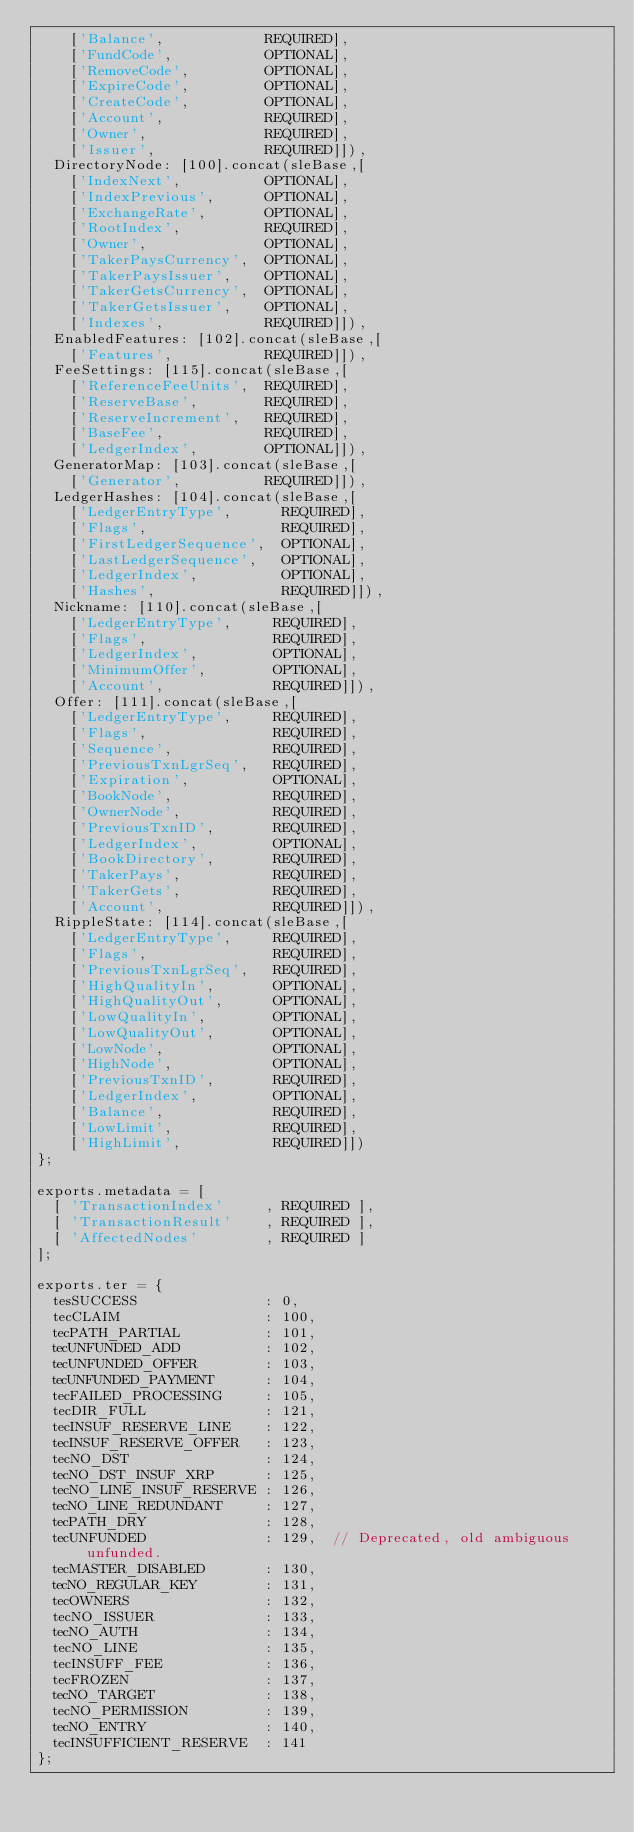<code> <loc_0><loc_0><loc_500><loc_500><_JavaScript_>    ['Balance',            REQUIRED],
    ['FundCode',           OPTIONAL],
    ['RemoveCode',         OPTIONAL],
    ['ExpireCode',         OPTIONAL],
    ['CreateCode',         OPTIONAL],
    ['Account',            REQUIRED],
    ['Owner',              REQUIRED],
    ['Issuer',             REQUIRED]]),
  DirectoryNode: [100].concat(sleBase,[
    ['IndexNext',          OPTIONAL],
    ['IndexPrevious',      OPTIONAL],
    ['ExchangeRate',       OPTIONAL],
    ['RootIndex',          REQUIRED],
    ['Owner',              OPTIONAL],
    ['TakerPaysCurrency',  OPTIONAL],
    ['TakerPaysIssuer',    OPTIONAL],
    ['TakerGetsCurrency',  OPTIONAL],
    ['TakerGetsIssuer',    OPTIONAL],
    ['Indexes',            REQUIRED]]),
  EnabledFeatures: [102].concat(sleBase,[
    ['Features',           REQUIRED]]),
  FeeSettings: [115].concat(sleBase,[
    ['ReferenceFeeUnits',  REQUIRED],
    ['ReserveBase',        REQUIRED],
    ['ReserveIncrement',   REQUIRED],
    ['BaseFee',            REQUIRED],
    ['LedgerIndex',        OPTIONAL]]),
  GeneratorMap: [103].concat(sleBase,[
    ['Generator',          REQUIRED]]),
  LedgerHashes: [104].concat(sleBase,[
    ['LedgerEntryType',      REQUIRED],
    ['Flags',                REQUIRED],
    ['FirstLedgerSequence',  OPTIONAL],
    ['LastLedgerSequence',   OPTIONAL],
    ['LedgerIndex',          OPTIONAL],
    ['Hashes',               REQUIRED]]),
  Nickname: [110].concat(sleBase,[
    ['LedgerEntryType',     REQUIRED],
    ['Flags',               REQUIRED],
    ['LedgerIndex',         OPTIONAL],
    ['MinimumOffer',        OPTIONAL],
    ['Account',             REQUIRED]]),
  Offer: [111].concat(sleBase,[
    ['LedgerEntryType',     REQUIRED],
    ['Flags',               REQUIRED],
    ['Sequence',            REQUIRED],
    ['PreviousTxnLgrSeq',   REQUIRED],
    ['Expiration',          OPTIONAL],
    ['BookNode',            REQUIRED],
    ['OwnerNode',           REQUIRED],
    ['PreviousTxnID',       REQUIRED],
    ['LedgerIndex',         OPTIONAL],
    ['BookDirectory',       REQUIRED],
    ['TakerPays',           REQUIRED],
    ['TakerGets',           REQUIRED],
    ['Account',             REQUIRED]]),
  RippleState: [114].concat(sleBase,[
    ['LedgerEntryType',     REQUIRED],
    ['Flags',               REQUIRED],
    ['PreviousTxnLgrSeq',   REQUIRED],
    ['HighQualityIn',       OPTIONAL],
    ['HighQualityOut',      OPTIONAL],
    ['LowQualityIn',        OPTIONAL],
    ['LowQualityOut',       OPTIONAL],
    ['LowNode',             OPTIONAL],
    ['HighNode',            OPTIONAL],
    ['PreviousTxnID',       REQUIRED],
    ['LedgerIndex',         OPTIONAL],
    ['Balance',             REQUIRED],
    ['LowLimit',            REQUIRED],
    ['HighLimit',           REQUIRED]])
};

exports.metadata = [
  [ 'TransactionIndex'     , REQUIRED ],
  [ 'TransactionResult'    , REQUIRED ],
  [ 'AffectedNodes'        , REQUIRED ]
];

exports.ter = {
  tesSUCCESS               : 0,
  tecCLAIM                 : 100,
  tecPATH_PARTIAL          : 101,
  tecUNFUNDED_ADD          : 102,
  tecUNFUNDED_OFFER        : 103,
  tecUNFUNDED_PAYMENT      : 104,
  tecFAILED_PROCESSING     : 105,
  tecDIR_FULL              : 121,
  tecINSUF_RESERVE_LINE    : 122,
  tecINSUF_RESERVE_OFFER   : 123,
  tecNO_DST                : 124,
  tecNO_DST_INSUF_XRP      : 125,
  tecNO_LINE_INSUF_RESERVE : 126,
  tecNO_LINE_REDUNDANT     : 127,
  tecPATH_DRY              : 128,
  tecUNFUNDED              : 129,  // Deprecated, old ambiguous unfunded.
  tecMASTER_DISABLED       : 130,
  tecNO_REGULAR_KEY        : 131,
  tecOWNERS                : 132,
  tecNO_ISSUER             : 133,
  tecNO_AUTH               : 134,
  tecNO_LINE               : 135,
  tecINSUFF_FEE            : 136,
  tecFROZEN                : 137,
  tecNO_TARGET             : 138,
  tecNO_PERMISSION         : 139,
  tecNO_ENTRY              : 140,
  tecINSUFFICIENT_RESERVE  : 141
};
</code> 